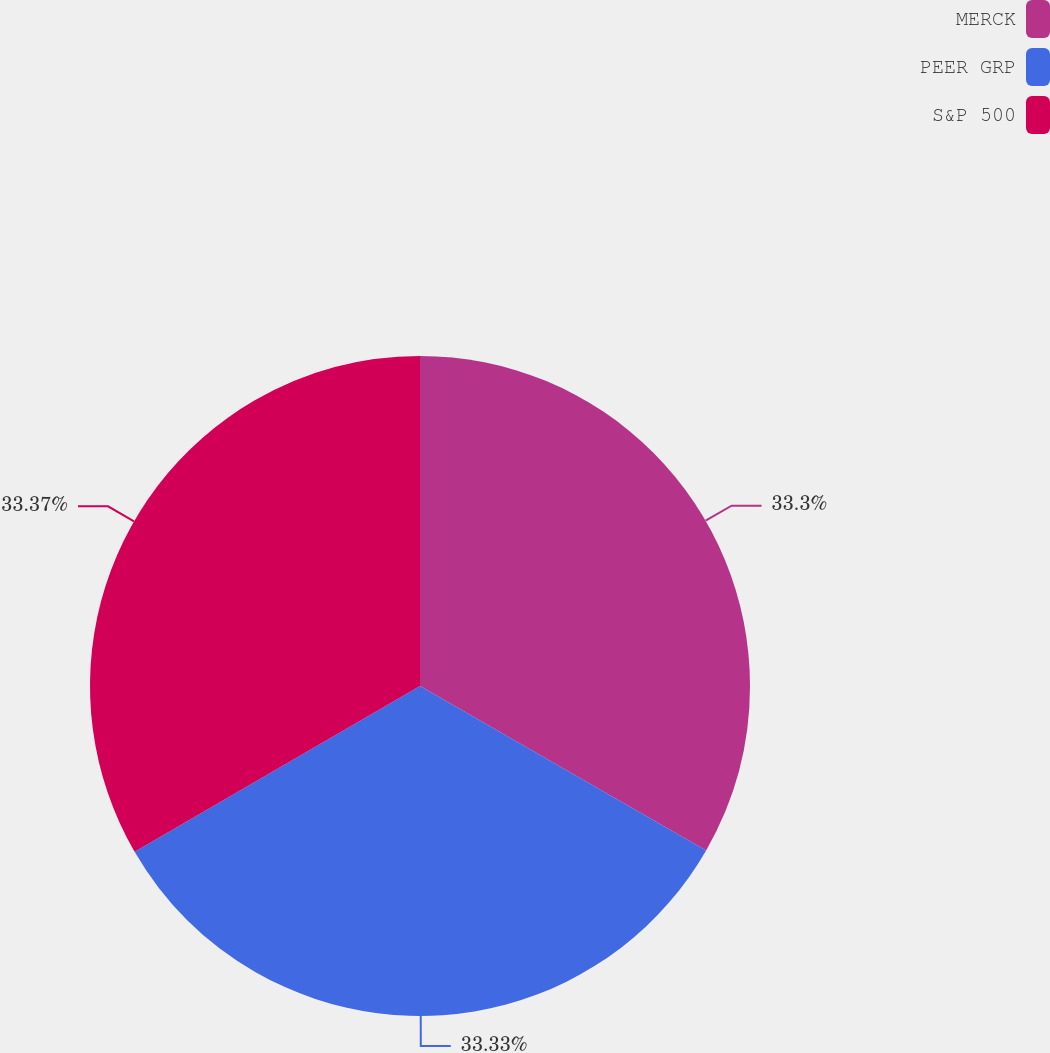<chart> <loc_0><loc_0><loc_500><loc_500><pie_chart><fcel>MERCK<fcel>PEER GRP<fcel>S&P 500<nl><fcel>33.3%<fcel>33.33%<fcel>33.37%<nl></chart> 